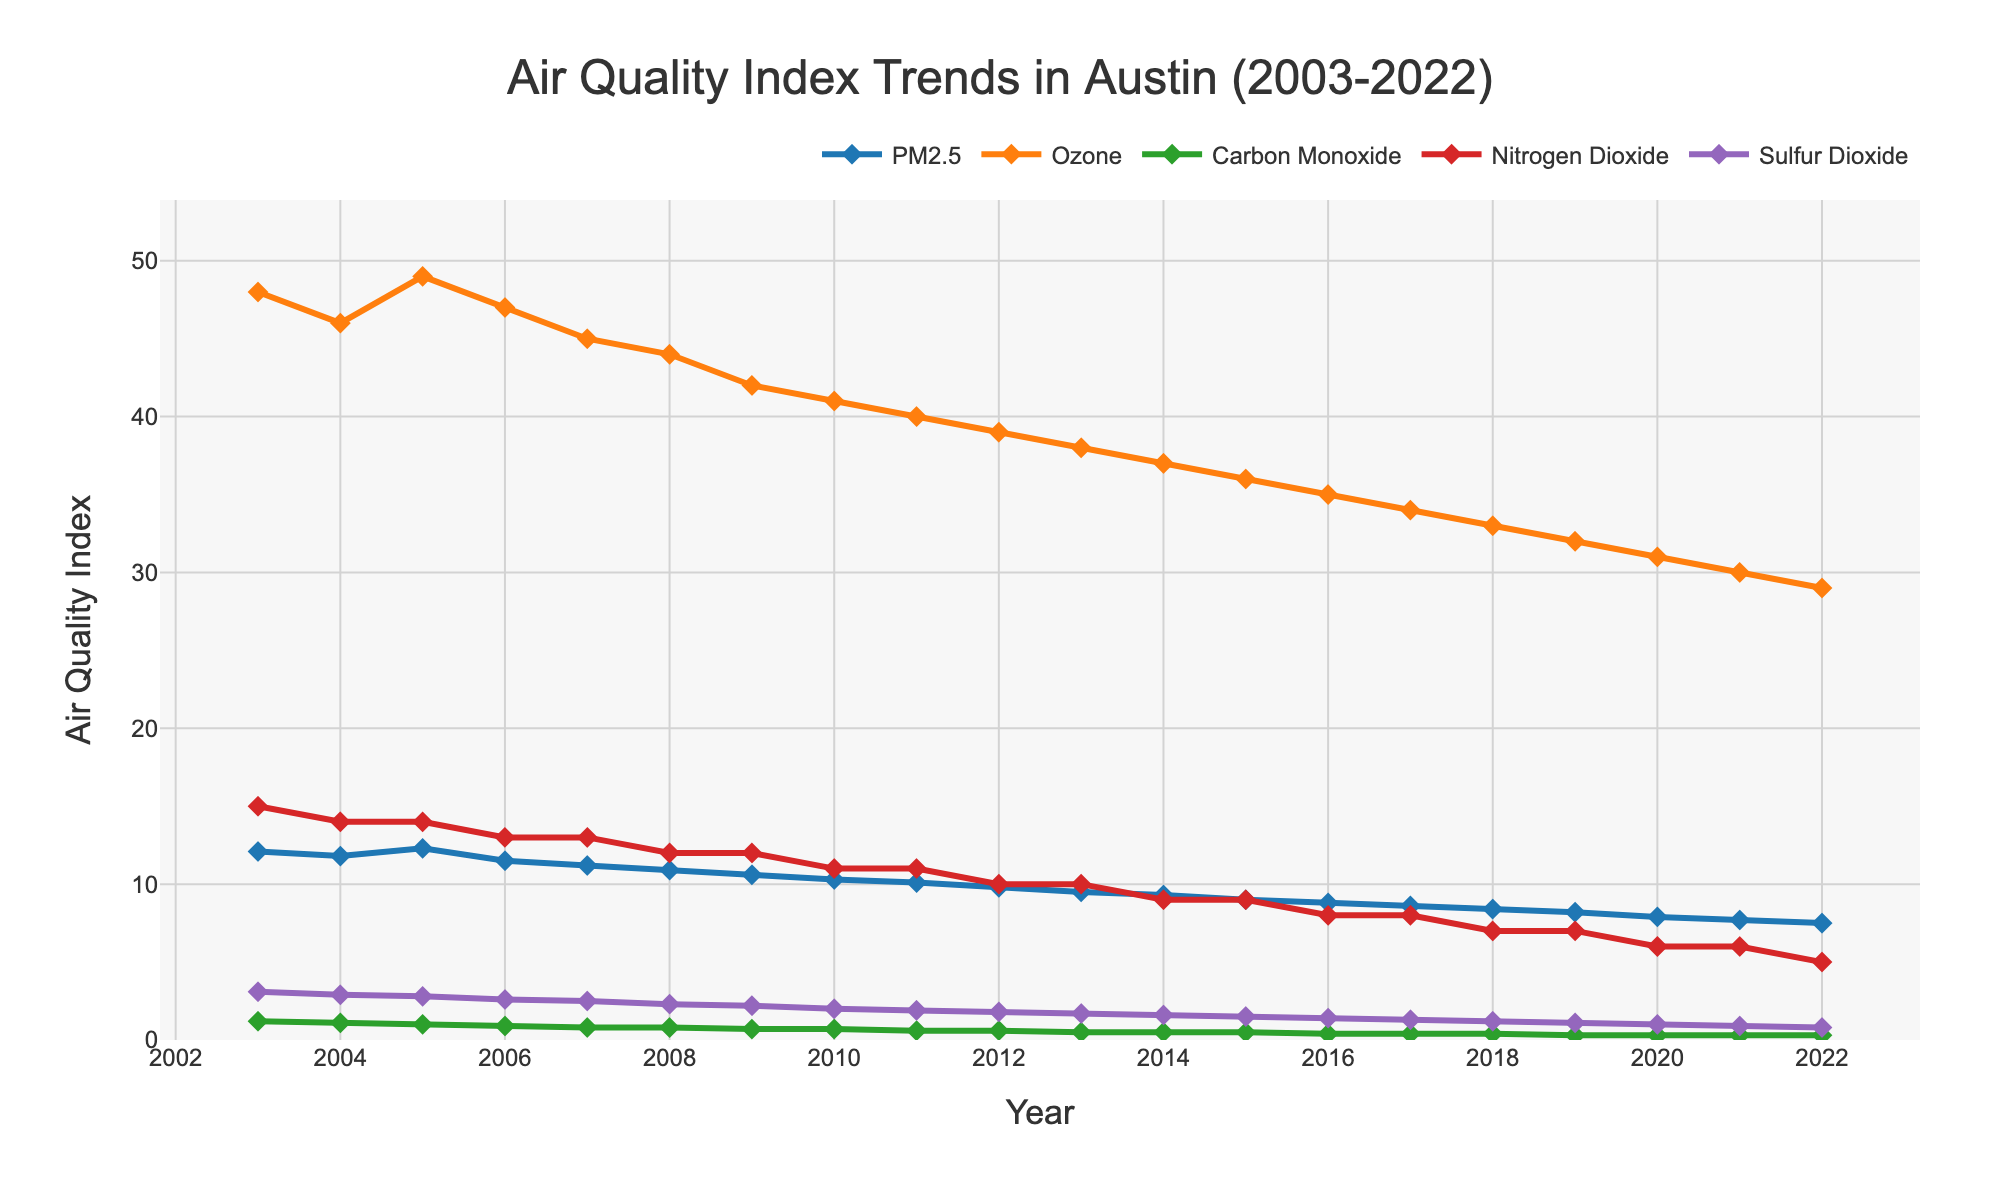Which year had the highest PM2.5 level? To determine this, we need to find the year corresponding to the highest point for the PM2.5 line in the chart. The line reaches its peak at 2005 with a value of 12.3.
Answer: 2005 How has the Ozone trend changed from 2003 to 2022? To answer this, identify the Ozone values at the beginning (2003) and the end (2022) and observe the general trend. Ozone levels decreased from 48 in 2003 to 29 in 2022, showing a downward trend.
Answer: Decreased Which pollutant experienced the most significant overall reduction from 2003 to 2022? Compare the difference between the 2003 and 2022 values for each pollutant. PM2.5 dropped from 12.1 to 7.5, Ozone from 48 to 29, Carbon Monoxide from 1.2 to 0.3, Nitrogen Dioxide from 15 to 5, and Sulfur Dioxide from 3.1 to 0.8. The largest reduction in values is seen in Nitrogen Dioxide, which reduced by 10.
Answer: Nitrogen Dioxide In which year did Carbon Monoxide levels first drop below 1.0? Identify the year where the Carbon Monoxide line first falls below the value of 1.0. This occurs in 2005 where the level is 1.0, but it first drops below in 2006 at 0.9.
Answer: 2006 What's the average PM2.5 level over the first 5 years (2003-2007)? To calculate the average PM2.5 for 2003-2007, sum the PM2.5 values for these years and divide by 5. The values are 12.1, 11.8, 12.3, 11.5, and 11.2, summing up to 58.9. Dividing by 5 gives an average of 58.9/5 = 11.78.
Answer: 11.78 Which pollutant shows the lowest levels in 2022? Look at the values for all pollutants in the year 2022. The values are: PM2.5 = 7.5, Ozone = 29, Carbon Monoxide = 0.3, Nitrogen Dioxide = 5, and Sulfur Dioxide = 0.8. The lowest value is for Carbon Monoxide at 0.3.
Answer: Carbon Monoxide Compare the trends of Ozone and PM2.5. Which one has decreased more rapidly? Calculate the difference in levels from 2003 to 2022 for both pollutants. Ozone decreased from 48 to 29 (a decrease of 19), and PM2.5 decreased from 12.1 to 7.5 (a decrease of 4.6). Ozone shows a more rapid decrease.
Answer: Ozone What is the total reduction in Sulfur Dioxide levels from 2003 to 2022? Calculate the difference between the 2003 and 2022 values for Sulfur Dioxide. The levels decreased from 3.1 to 0.8, giving a total reduction of 3.1 - 0.8 = 2.3.
Answer: 2.3 In which range do most Nitrogen Dioxide values fall? Observe the vertical range where the majority of the Nitrogen Dioxide points fall. The values mostly lie between 5 and 15.
Answer: 5 to 15 Which pollutant shows the steadiest decline over the years? Examine the lines representing each pollutant to see which one has the smoothest downward trend. Ozone, PM2.5, and Nitrogen Dioxide all show steady declines, but PM2.5 appears consistently smooth and gradual.
Answer: PM2.5 